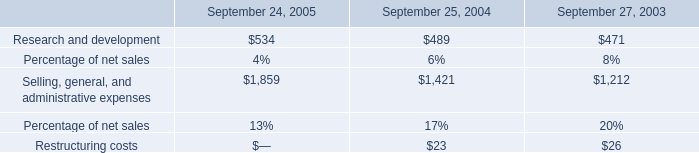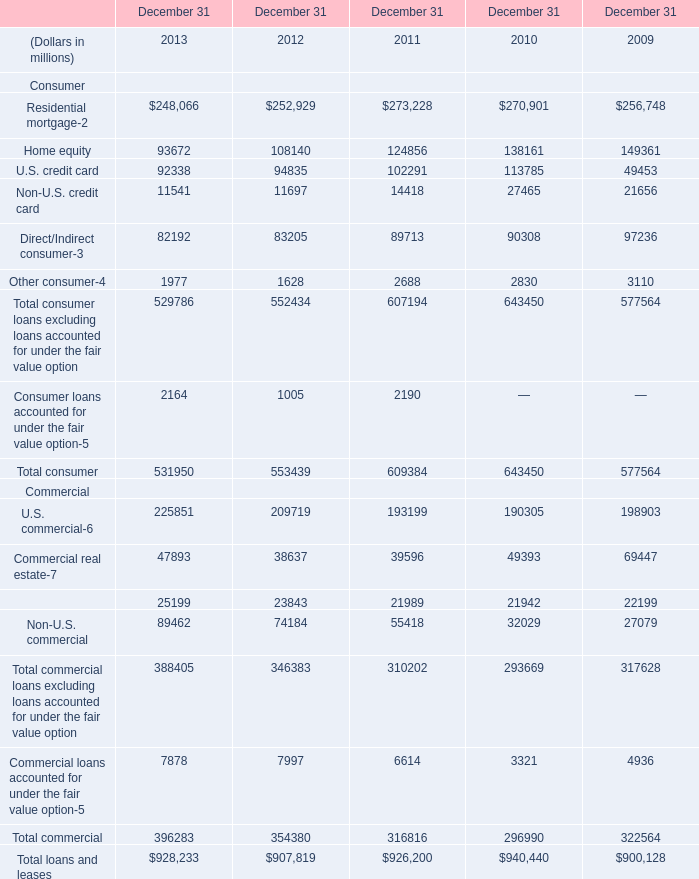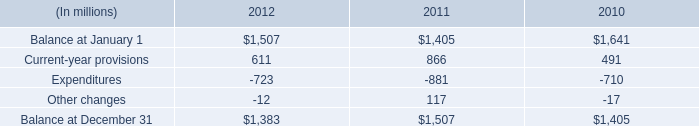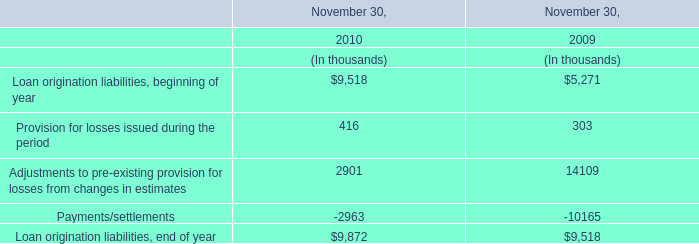What's the average of Commercial lease financing Commercial of December 31 2009, and Balance at December 31 of 2012 ? 
Computations: ((22199.0 + 1383.0) / 2)
Answer: 11791.0. 